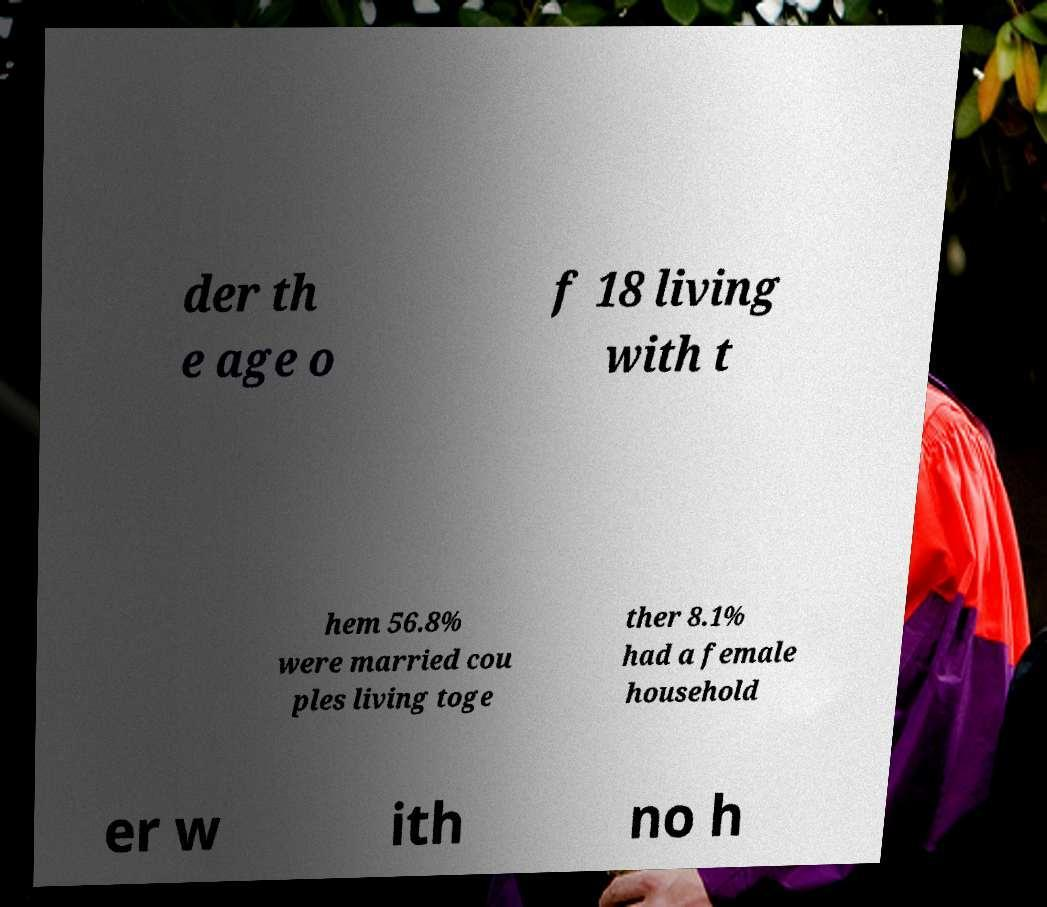Please identify and transcribe the text found in this image. der th e age o f 18 living with t hem 56.8% were married cou ples living toge ther 8.1% had a female household er w ith no h 